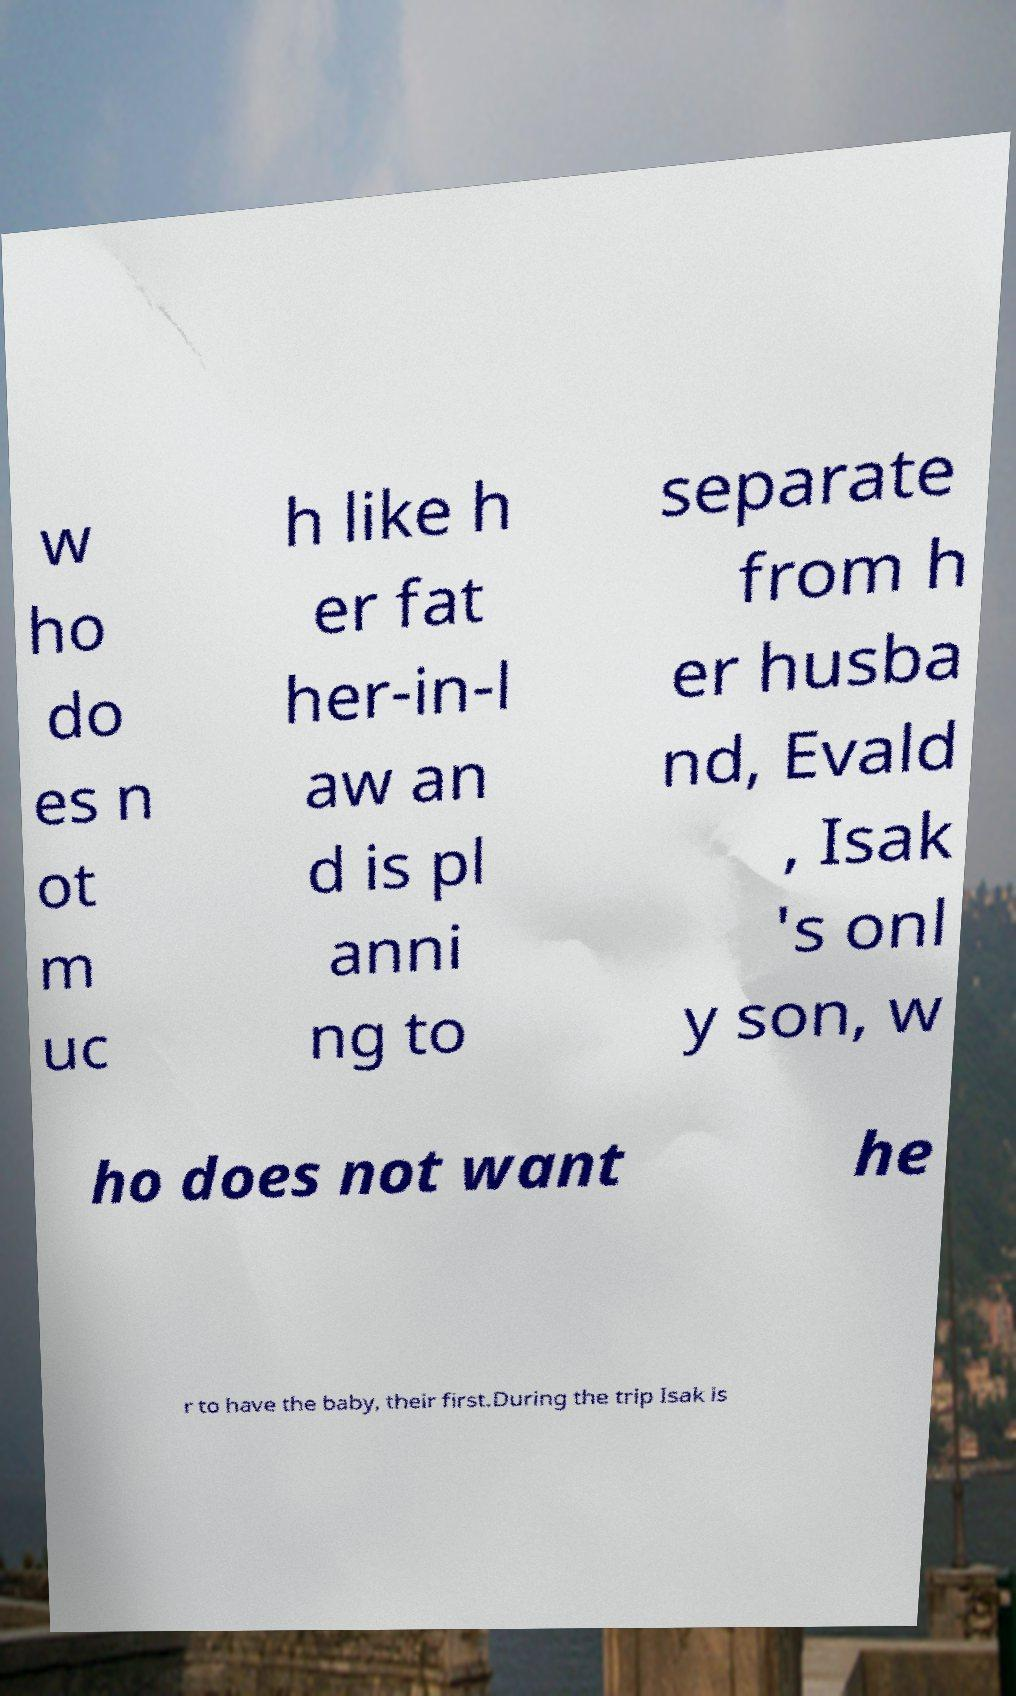Could you assist in decoding the text presented in this image and type it out clearly? w ho do es n ot m uc h like h er fat her-in-l aw an d is pl anni ng to separate from h er husba nd, Evald , Isak 's onl y son, w ho does not want he r to have the baby, their first.During the trip Isak is 